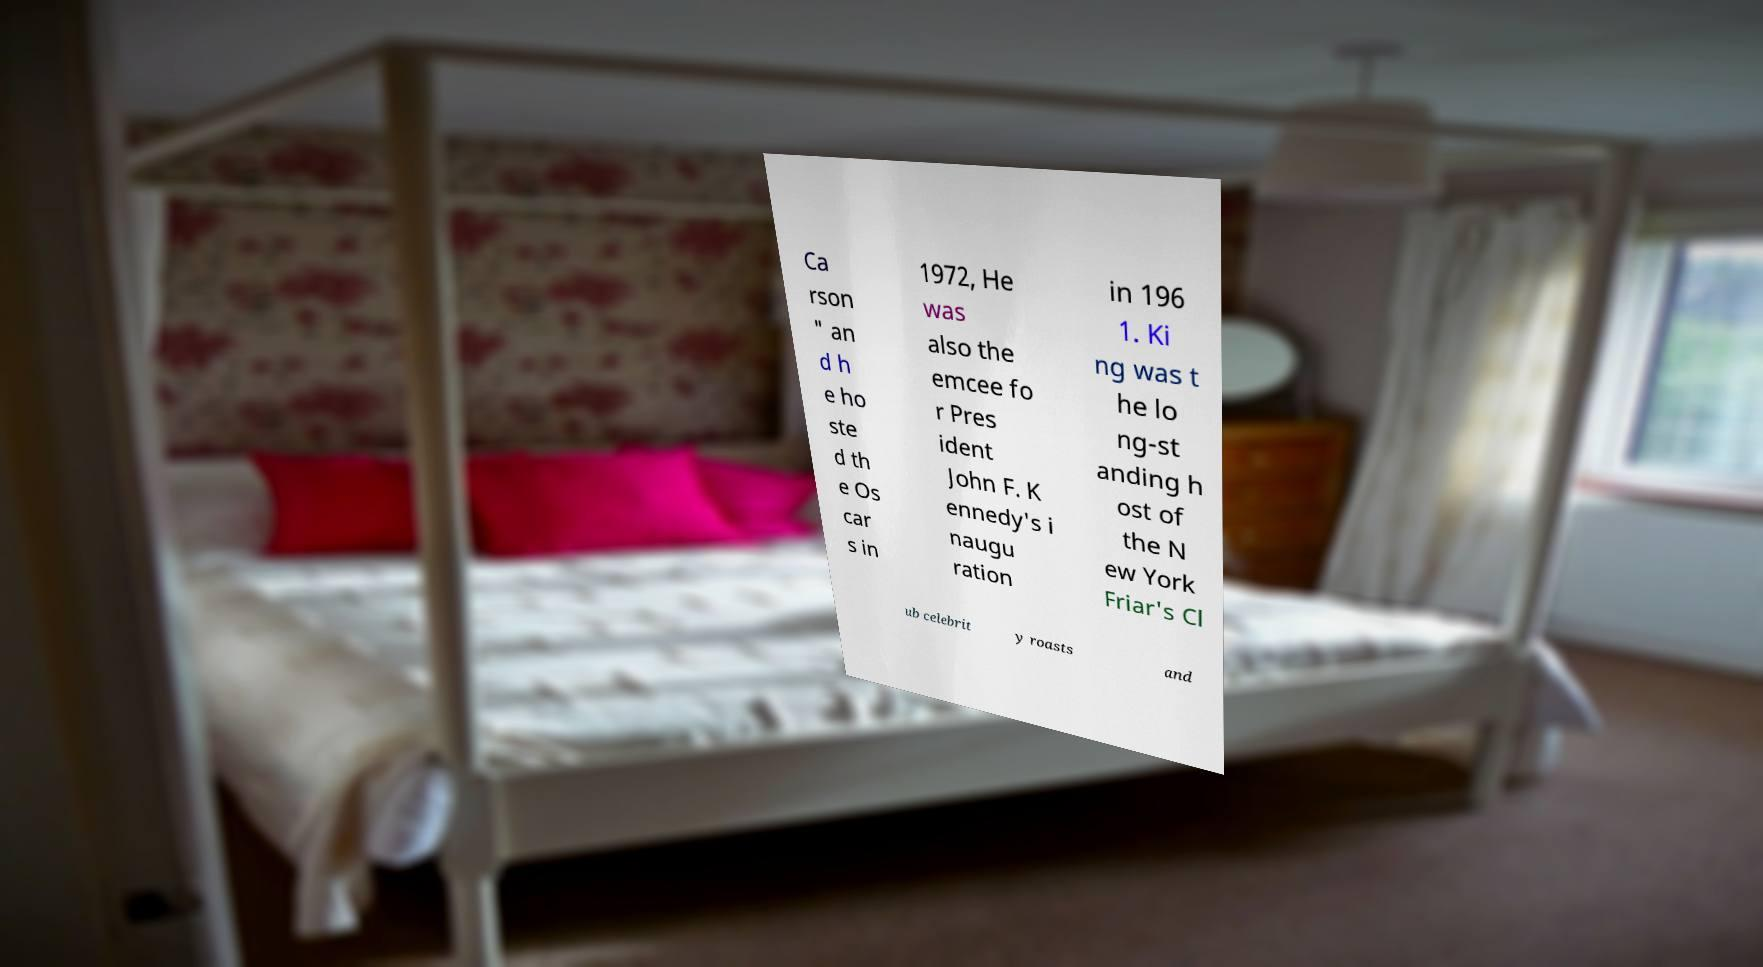Could you extract and type out the text from this image? Ca rson " an d h e ho ste d th e Os car s in 1972, He was also the emcee fo r Pres ident John F. K ennedy's i naugu ration in 196 1. Ki ng was t he lo ng-st anding h ost of the N ew York Friar's Cl ub celebrit y roasts and 